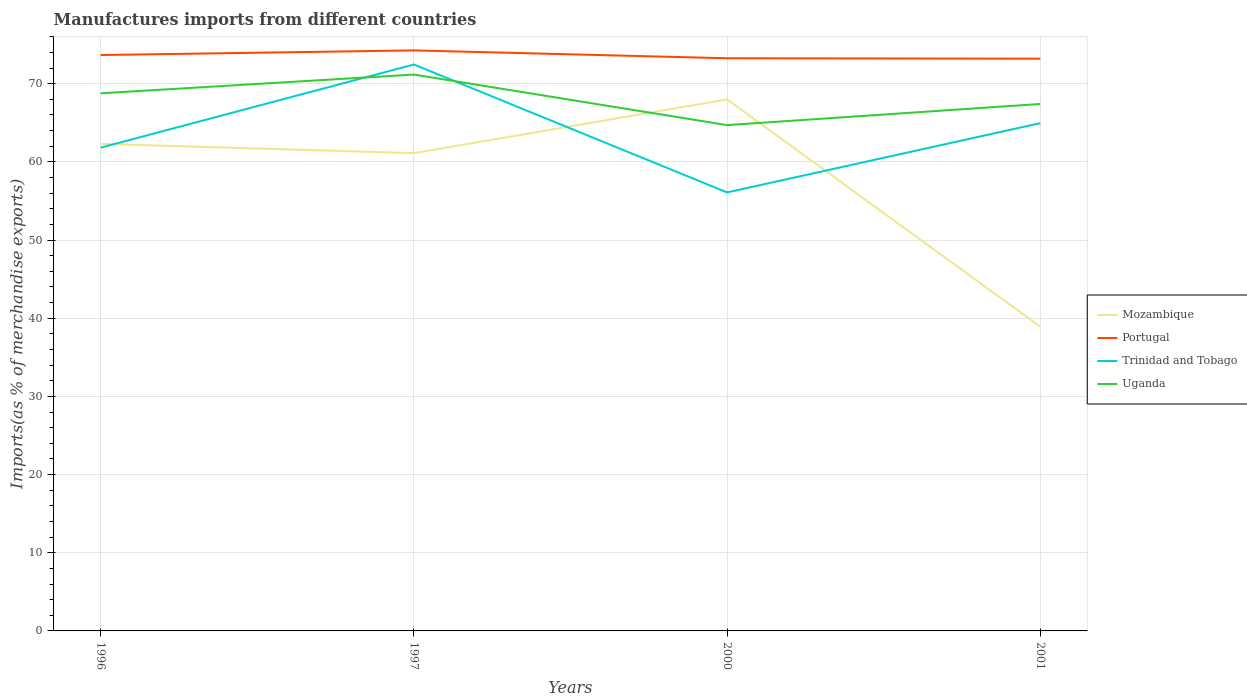Is the number of lines equal to the number of legend labels?
Keep it short and to the point. Yes. Across all years, what is the maximum percentage of imports to different countries in Uganda?
Make the answer very short. 64.7. In which year was the percentage of imports to different countries in Mozambique maximum?
Provide a short and direct response. 2001. What is the total percentage of imports to different countries in Uganda in the graph?
Offer a very short reply. 3.76. What is the difference between the highest and the second highest percentage of imports to different countries in Portugal?
Offer a terse response. 1.06. How many legend labels are there?
Keep it short and to the point. 4. How are the legend labels stacked?
Offer a terse response. Vertical. What is the title of the graph?
Provide a short and direct response. Manufactures imports from different countries. Does "Kosovo" appear as one of the legend labels in the graph?
Ensure brevity in your answer.  No. What is the label or title of the X-axis?
Offer a very short reply. Years. What is the label or title of the Y-axis?
Keep it short and to the point. Imports(as % of merchandise exports). What is the Imports(as % of merchandise exports) in Mozambique in 1996?
Keep it short and to the point. 62.31. What is the Imports(as % of merchandise exports) in Portugal in 1996?
Keep it short and to the point. 73.67. What is the Imports(as % of merchandise exports) of Trinidad and Tobago in 1996?
Give a very brief answer. 61.82. What is the Imports(as % of merchandise exports) of Uganda in 1996?
Your answer should be very brief. 68.77. What is the Imports(as % of merchandise exports) in Mozambique in 1997?
Make the answer very short. 61.12. What is the Imports(as % of merchandise exports) of Portugal in 1997?
Offer a terse response. 74.26. What is the Imports(as % of merchandise exports) of Trinidad and Tobago in 1997?
Provide a short and direct response. 72.46. What is the Imports(as % of merchandise exports) of Uganda in 1997?
Offer a terse response. 71.17. What is the Imports(as % of merchandise exports) in Mozambique in 2000?
Your answer should be compact. 67.99. What is the Imports(as % of merchandise exports) of Portugal in 2000?
Make the answer very short. 73.26. What is the Imports(as % of merchandise exports) in Trinidad and Tobago in 2000?
Keep it short and to the point. 56.1. What is the Imports(as % of merchandise exports) in Uganda in 2000?
Provide a succinct answer. 64.7. What is the Imports(as % of merchandise exports) of Mozambique in 2001?
Your answer should be compact. 38.92. What is the Imports(as % of merchandise exports) of Portugal in 2001?
Give a very brief answer. 73.2. What is the Imports(as % of merchandise exports) in Trinidad and Tobago in 2001?
Offer a terse response. 64.95. What is the Imports(as % of merchandise exports) of Uganda in 2001?
Keep it short and to the point. 67.41. Across all years, what is the maximum Imports(as % of merchandise exports) of Mozambique?
Your response must be concise. 67.99. Across all years, what is the maximum Imports(as % of merchandise exports) of Portugal?
Keep it short and to the point. 74.26. Across all years, what is the maximum Imports(as % of merchandise exports) in Trinidad and Tobago?
Your answer should be very brief. 72.46. Across all years, what is the maximum Imports(as % of merchandise exports) of Uganda?
Ensure brevity in your answer.  71.17. Across all years, what is the minimum Imports(as % of merchandise exports) in Mozambique?
Your answer should be very brief. 38.92. Across all years, what is the minimum Imports(as % of merchandise exports) in Portugal?
Your answer should be very brief. 73.2. Across all years, what is the minimum Imports(as % of merchandise exports) in Trinidad and Tobago?
Provide a succinct answer. 56.1. Across all years, what is the minimum Imports(as % of merchandise exports) in Uganda?
Your answer should be compact. 64.7. What is the total Imports(as % of merchandise exports) of Mozambique in the graph?
Your answer should be very brief. 230.34. What is the total Imports(as % of merchandise exports) of Portugal in the graph?
Your response must be concise. 294.39. What is the total Imports(as % of merchandise exports) in Trinidad and Tobago in the graph?
Your answer should be very brief. 255.33. What is the total Imports(as % of merchandise exports) of Uganda in the graph?
Ensure brevity in your answer.  272.06. What is the difference between the Imports(as % of merchandise exports) in Mozambique in 1996 and that in 1997?
Your answer should be very brief. 1.19. What is the difference between the Imports(as % of merchandise exports) in Portugal in 1996 and that in 1997?
Your answer should be compact. -0.6. What is the difference between the Imports(as % of merchandise exports) in Trinidad and Tobago in 1996 and that in 1997?
Provide a succinct answer. -10.64. What is the difference between the Imports(as % of merchandise exports) in Uganda in 1996 and that in 1997?
Your answer should be compact. -2.4. What is the difference between the Imports(as % of merchandise exports) in Mozambique in 1996 and that in 2000?
Offer a very short reply. -5.68. What is the difference between the Imports(as % of merchandise exports) of Portugal in 1996 and that in 2000?
Make the answer very short. 0.41. What is the difference between the Imports(as % of merchandise exports) of Trinidad and Tobago in 1996 and that in 2000?
Your answer should be compact. 5.73. What is the difference between the Imports(as % of merchandise exports) in Uganda in 1996 and that in 2000?
Your answer should be compact. 4.07. What is the difference between the Imports(as % of merchandise exports) of Mozambique in 1996 and that in 2001?
Provide a short and direct response. 23.39. What is the difference between the Imports(as % of merchandise exports) of Portugal in 1996 and that in 2001?
Provide a succinct answer. 0.47. What is the difference between the Imports(as % of merchandise exports) of Trinidad and Tobago in 1996 and that in 2001?
Your answer should be very brief. -3.13. What is the difference between the Imports(as % of merchandise exports) in Uganda in 1996 and that in 2001?
Your answer should be compact. 1.36. What is the difference between the Imports(as % of merchandise exports) in Mozambique in 1997 and that in 2000?
Your response must be concise. -6.88. What is the difference between the Imports(as % of merchandise exports) of Portugal in 1997 and that in 2000?
Provide a short and direct response. 1.01. What is the difference between the Imports(as % of merchandise exports) of Trinidad and Tobago in 1997 and that in 2000?
Your response must be concise. 16.36. What is the difference between the Imports(as % of merchandise exports) in Uganda in 1997 and that in 2000?
Your answer should be very brief. 6.46. What is the difference between the Imports(as % of merchandise exports) in Mozambique in 1997 and that in 2001?
Make the answer very short. 22.2. What is the difference between the Imports(as % of merchandise exports) in Portugal in 1997 and that in 2001?
Give a very brief answer. 1.06. What is the difference between the Imports(as % of merchandise exports) of Trinidad and Tobago in 1997 and that in 2001?
Keep it short and to the point. 7.5. What is the difference between the Imports(as % of merchandise exports) in Uganda in 1997 and that in 2001?
Your answer should be very brief. 3.76. What is the difference between the Imports(as % of merchandise exports) in Mozambique in 2000 and that in 2001?
Offer a very short reply. 29.07. What is the difference between the Imports(as % of merchandise exports) of Portugal in 2000 and that in 2001?
Offer a very short reply. 0.05. What is the difference between the Imports(as % of merchandise exports) of Trinidad and Tobago in 2000 and that in 2001?
Provide a short and direct response. -8.86. What is the difference between the Imports(as % of merchandise exports) of Uganda in 2000 and that in 2001?
Offer a terse response. -2.7. What is the difference between the Imports(as % of merchandise exports) in Mozambique in 1996 and the Imports(as % of merchandise exports) in Portugal in 1997?
Give a very brief answer. -11.95. What is the difference between the Imports(as % of merchandise exports) of Mozambique in 1996 and the Imports(as % of merchandise exports) of Trinidad and Tobago in 1997?
Provide a succinct answer. -10.15. What is the difference between the Imports(as % of merchandise exports) of Mozambique in 1996 and the Imports(as % of merchandise exports) of Uganda in 1997?
Ensure brevity in your answer.  -8.86. What is the difference between the Imports(as % of merchandise exports) in Portugal in 1996 and the Imports(as % of merchandise exports) in Trinidad and Tobago in 1997?
Your response must be concise. 1.21. What is the difference between the Imports(as % of merchandise exports) in Portugal in 1996 and the Imports(as % of merchandise exports) in Uganda in 1997?
Ensure brevity in your answer.  2.5. What is the difference between the Imports(as % of merchandise exports) of Trinidad and Tobago in 1996 and the Imports(as % of merchandise exports) of Uganda in 1997?
Ensure brevity in your answer.  -9.35. What is the difference between the Imports(as % of merchandise exports) in Mozambique in 1996 and the Imports(as % of merchandise exports) in Portugal in 2000?
Ensure brevity in your answer.  -10.95. What is the difference between the Imports(as % of merchandise exports) of Mozambique in 1996 and the Imports(as % of merchandise exports) of Trinidad and Tobago in 2000?
Your answer should be compact. 6.21. What is the difference between the Imports(as % of merchandise exports) in Mozambique in 1996 and the Imports(as % of merchandise exports) in Uganda in 2000?
Offer a very short reply. -2.4. What is the difference between the Imports(as % of merchandise exports) in Portugal in 1996 and the Imports(as % of merchandise exports) in Trinidad and Tobago in 2000?
Your answer should be very brief. 17.57. What is the difference between the Imports(as % of merchandise exports) of Portugal in 1996 and the Imports(as % of merchandise exports) of Uganda in 2000?
Make the answer very short. 8.96. What is the difference between the Imports(as % of merchandise exports) of Trinidad and Tobago in 1996 and the Imports(as % of merchandise exports) of Uganda in 2000?
Offer a very short reply. -2.88. What is the difference between the Imports(as % of merchandise exports) of Mozambique in 1996 and the Imports(as % of merchandise exports) of Portugal in 2001?
Your answer should be very brief. -10.89. What is the difference between the Imports(as % of merchandise exports) in Mozambique in 1996 and the Imports(as % of merchandise exports) in Trinidad and Tobago in 2001?
Ensure brevity in your answer.  -2.65. What is the difference between the Imports(as % of merchandise exports) of Mozambique in 1996 and the Imports(as % of merchandise exports) of Uganda in 2001?
Provide a succinct answer. -5.1. What is the difference between the Imports(as % of merchandise exports) of Portugal in 1996 and the Imports(as % of merchandise exports) of Trinidad and Tobago in 2001?
Offer a terse response. 8.71. What is the difference between the Imports(as % of merchandise exports) in Portugal in 1996 and the Imports(as % of merchandise exports) in Uganda in 2001?
Provide a short and direct response. 6.26. What is the difference between the Imports(as % of merchandise exports) of Trinidad and Tobago in 1996 and the Imports(as % of merchandise exports) of Uganda in 2001?
Give a very brief answer. -5.59. What is the difference between the Imports(as % of merchandise exports) in Mozambique in 1997 and the Imports(as % of merchandise exports) in Portugal in 2000?
Offer a very short reply. -12.14. What is the difference between the Imports(as % of merchandise exports) in Mozambique in 1997 and the Imports(as % of merchandise exports) in Trinidad and Tobago in 2000?
Provide a short and direct response. 5.02. What is the difference between the Imports(as % of merchandise exports) in Mozambique in 1997 and the Imports(as % of merchandise exports) in Uganda in 2000?
Your response must be concise. -3.59. What is the difference between the Imports(as % of merchandise exports) in Portugal in 1997 and the Imports(as % of merchandise exports) in Trinidad and Tobago in 2000?
Offer a very short reply. 18.17. What is the difference between the Imports(as % of merchandise exports) in Portugal in 1997 and the Imports(as % of merchandise exports) in Uganda in 2000?
Your answer should be very brief. 9.56. What is the difference between the Imports(as % of merchandise exports) of Trinidad and Tobago in 1997 and the Imports(as % of merchandise exports) of Uganda in 2000?
Provide a succinct answer. 7.75. What is the difference between the Imports(as % of merchandise exports) in Mozambique in 1997 and the Imports(as % of merchandise exports) in Portugal in 2001?
Make the answer very short. -12.09. What is the difference between the Imports(as % of merchandise exports) of Mozambique in 1997 and the Imports(as % of merchandise exports) of Trinidad and Tobago in 2001?
Make the answer very short. -3.84. What is the difference between the Imports(as % of merchandise exports) in Mozambique in 1997 and the Imports(as % of merchandise exports) in Uganda in 2001?
Make the answer very short. -6.29. What is the difference between the Imports(as % of merchandise exports) of Portugal in 1997 and the Imports(as % of merchandise exports) of Trinidad and Tobago in 2001?
Offer a very short reply. 9.31. What is the difference between the Imports(as % of merchandise exports) of Portugal in 1997 and the Imports(as % of merchandise exports) of Uganda in 2001?
Offer a terse response. 6.85. What is the difference between the Imports(as % of merchandise exports) of Trinidad and Tobago in 1997 and the Imports(as % of merchandise exports) of Uganda in 2001?
Give a very brief answer. 5.05. What is the difference between the Imports(as % of merchandise exports) in Mozambique in 2000 and the Imports(as % of merchandise exports) in Portugal in 2001?
Ensure brevity in your answer.  -5.21. What is the difference between the Imports(as % of merchandise exports) of Mozambique in 2000 and the Imports(as % of merchandise exports) of Trinidad and Tobago in 2001?
Your answer should be very brief. 3.04. What is the difference between the Imports(as % of merchandise exports) in Mozambique in 2000 and the Imports(as % of merchandise exports) in Uganda in 2001?
Make the answer very short. 0.58. What is the difference between the Imports(as % of merchandise exports) of Portugal in 2000 and the Imports(as % of merchandise exports) of Trinidad and Tobago in 2001?
Make the answer very short. 8.3. What is the difference between the Imports(as % of merchandise exports) of Portugal in 2000 and the Imports(as % of merchandise exports) of Uganda in 2001?
Your response must be concise. 5.85. What is the difference between the Imports(as % of merchandise exports) in Trinidad and Tobago in 2000 and the Imports(as % of merchandise exports) in Uganda in 2001?
Keep it short and to the point. -11.31. What is the average Imports(as % of merchandise exports) of Mozambique per year?
Give a very brief answer. 57.58. What is the average Imports(as % of merchandise exports) of Portugal per year?
Provide a succinct answer. 73.6. What is the average Imports(as % of merchandise exports) in Trinidad and Tobago per year?
Your answer should be compact. 63.83. What is the average Imports(as % of merchandise exports) in Uganda per year?
Provide a short and direct response. 68.01. In the year 1996, what is the difference between the Imports(as % of merchandise exports) of Mozambique and Imports(as % of merchandise exports) of Portugal?
Keep it short and to the point. -11.36. In the year 1996, what is the difference between the Imports(as % of merchandise exports) of Mozambique and Imports(as % of merchandise exports) of Trinidad and Tobago?
Keep it short and to the point. 0.49. In the year 1996, what is the difference between the Imports(as % of merchandise exports) of Mozambique and Imports(as % of merchandise exports) of Uganda?
Give a very brief answer. -6.47. In the year 1996, what is the difference between the Imports(as % of merchandise exports) in Portugal and Imports(as % of merchandise exports) in Trinidad and Tobago?
Your response must be concise. 11.85. In the year 1996, what is the difference between the Imports(as % of merchandise exports) of Portugal and Imports(as % of merchandise exports) of Uganda?
Keep it short and to the point. 4.89. In the year 1996, what is the difference between the Imports(as % of merchandise exports) of Trinidad and Tobago and Imports(as % of merchandise exports) of Uganda?
Your answer should be very brief. -6.95. In the year 1997, what is the difference between the Imports(as % of merchandise exports) in Mozambique and Imports(as % of merchandise exports) in Portugal?
Provide a succinct answer. -13.15. In the year 1997, what is the difference between the Imports(as % of merchandise exports) in Mozambique and Imports(as % of merchandise exports) in Trinidad and Tobago?
Offer a very short reply. -11.34. In the year 1997, what is the difference between the Imports(as % of merchandise exports) in Mozambique and Imports(as % of merchandise exports) in Uganda?
Give a very brief answer. -10.05. In the year 1997, what is the difference between the Imports(as % of merchandise exports) in Portugal and Imports(as % of merchandise exports) in Trinidad and Tobago?
Provide a short and direct response. 1.8. In the year 1997, what is the difference between the Imports(as % of merchandise exports) of Portugal and Imports(as % of merchandise exports) of Uganda?
Provide a succinct answer. 3.09. In the year 1997, what is the difference between the Imports(as % of merchandise exports) in Trinidad and Tobago and Imports(as % of merchandise exports) in Uganda?
Provide a succinct answer. 1.29. In the year 2000, what is the difference between the Imports(as % of merchandise exports) in Mozambique and Imports(as % of merchandise exports) in Portugal?
Your response must be concise. -5.26. In the year 2000, what is the difference between the Imports(as % of merchandise exports) of Mozambique and Imports(as % of merchandise exports) of Trinidad and Tobago?
Your answer should be compact. 11.9. In the year 2000, what is the difference between the Imports(as % of merchandise exports) of Mozambique and Imports(as % of merchandise exports) of Uganda?
Offer a terse response. 3.29. In the year 2000, what is the difference between the Imports(as % of merchandise exports) of Portugal and Imports(as % of merchandise exports) of Trinidad and Tobago?
Your answer should be very brief. 17.16. In the year 2000, what is the difference between the Imports(as % of merchandise exports) in Portugal and Imports(as % of merchandise exports) in Uganda?
Give a very brief answer. 8.55. In the year 2000, what is the difference between the Imports(as % of merchandise exports) of Trinidad and Tobago and Imports(as % of merchandise exports) of Uganda?
Give a very brief answer. -8.61. In the year 2001, what is the difference between the Imports(as % of merchandise exports) in Mozambique and Imports(as % of merchandise exports) in Portugal?
Ensure brevity in your answer.  -34.28. In the year 2001, what is the difference between the Imports(as % of merchandise exports) of Mozambique and Imports(as % of merchandise exports) of Trinidad and Tobago?
Give a very brief answer. -26.03. In the year 2001, what is the difference between the Imports(as % of merchandise exports) in Mozambique and Imports(as % of merchandise exports) in Uganda?
Your answer should be very brief. -28.49. In the year 2001, what is the difference between the Imports(as % of merchandise exports) in Portugal and Imports(as % of merchandise exports) in Trinidad and Tobago?
Your answer should be compact. 8.25. In the year 2001, what is the difference between the Imports(as % of merchandise exports) in Portugal and Imports(as % of merchandise exports) in Uganda?
Provide a short and direct response. 5.79. In the year 2001, what is the difference between the Imports(as % of merchandise exports) of Trinidad and Tobago and Imports(as % of merchandise exports) of Uganda?
Your answer should be very brief. -2.46. What is the ratio of the Imports(as % of merchandise exports) in Mozambique in 1996 to that in 1997?
Ensure brevity in your answer.  1.02. What is the ratio of the Imports(as % of merchandise exports) in Portugal in 1996 to that in 1997?
Your answer should be compact. 0.99. What is the ratio of the Imports(as % of merchandise exports) in Trinidad and Tobago in 1996 to that in 1997?
Keep it short and to the point. 0.85. What is the ratio of the Imports(as % of merchandise exports) in Uganda in 1996 to that in 1997?
Provide a short and direct response. 0.97. What is the ratio of the Imports(as % of merchandise exports) of Mozambique in 1996 to that in 2000?
Give a very brief answer. 0.92. What is the ratio of the Imports(as % of merchandise exports) in Portugal in 1996 to that in 2000?
Provide a short and direct response. 1.01. What is the ratio of the Imports(as % of merchandise exports) in Trinidad and Tobago in 1996 to that in 2000?
Provide a short and direct response. 1.1. What is the ratio of the Imports(as % of merchandise exports) of Uganda in 1996 to that in 2000?
Ensure brevity in your answer.  1.06. What is the ratio of the Imports(as % of merchandise exports) in Mozambique in 1996 to that in 2001?
Your response must be concise. 1.6. What is the ratio of the Imports(as % of merchandise exports) in Portugal in 1996 to that in 2001?
Offer a very short reply. 1.01. What is the ratio of the Imports(as % of merchandise exports) of Trinidad and Tobago in 1996 to that in 2001?
Keep it short and to the point. 0.95. What is the ratio of the Imports(as % of merchandise exports) of Uganda in 1996 to that in 2001?
Make the answer very short. 1.02. What is the ratio of the Imports(as % of merchandise exports) in Mozambique in 1997 to that in 2000?
Ensure brevity in your answer.  0.9. What is the ratio of the Imports(as % of merchandise exports) of Portugal in 1997 to that in 2000?
Keep it short and to the point. 1.01. What is the ratio of the Imports(as % of merchandise exports) of Trinidad and Tobago in 1997 to that in 2000?
Offer a terse response. 1.29. What is the ratio of the Imports(as % of merchandise exports) in Uganda in 1997 to that in 2000?
Offer a very short reply. 1.1. What is the ratio of the Imports(as % of merchandise exports) of Mozambique in 1997 to that in 2001?
Give a very brief answer. 1.57. What is the ratio of the Imports(as % of merchandise exports) of Portugal in 1997 to that in 2001?
Offer a very short reply. 1.01. What is the ratio of the Imports(as % of merchandise exports) of Trinidad and Tobago in 1997 to that in 2001?
Offer a terse response. 1.12. What is the ratio of the Imports(as % of merchandise exports) of Uganda in 1997 to that in 2001?
Your answer should be very brief. 1.06. What is the ratio of the Imports(as % of merchandise exports) in Mozambique in 2000 to that in 2001?
Provide a short and direct response. 1.75. What is the ratio of the Imports(as % of merchandise exports) in Trinidad and Tobago in 2000 to that in 2001?
Your answer should be very brief. 0.86. What is the ratio of the Imports(as % of merchandise exports) of Uganda in 2000 to that in 2001?
Provide a succinct answer. 0.96. What is the difference between the highest and the second highest Imports(as % of merchandise exports) of Mozambique?
Give a very brief answer. 5.68. What is the difference between the highest and the second highest Imports(as % of merchandise exports) in Portugal?
Provide a short and direct response. 0.6. What is the difference between the highest and the second highest Imports(as % of merchandise exports) of Trinidad and Tobago?
Offer a terse response. 7.5. What is the difference between the highest and the second highest Imports(as % of merchandise exports) of Uganda?
Your response must be concise. 2.4. What is the difference between the highest and the lowest Imports(as % of merchandise exports) in Mozambique?
Provide a short and direct response. 29.07. What is the difference between the highest and the lowest Imports(as % of merchandise exports) in Portugal?
Offer a very short reply. 1.06. What is the difference between the highest and the lowest Imports(as % of merchandise exports) in Trinidad and Tobago?
Provide a succinct answer. 16.36. What is the difference between the highest and the lowest Imports(as % of merchandise exports) in Uganda?
Your answer should be compact. 6.46. 